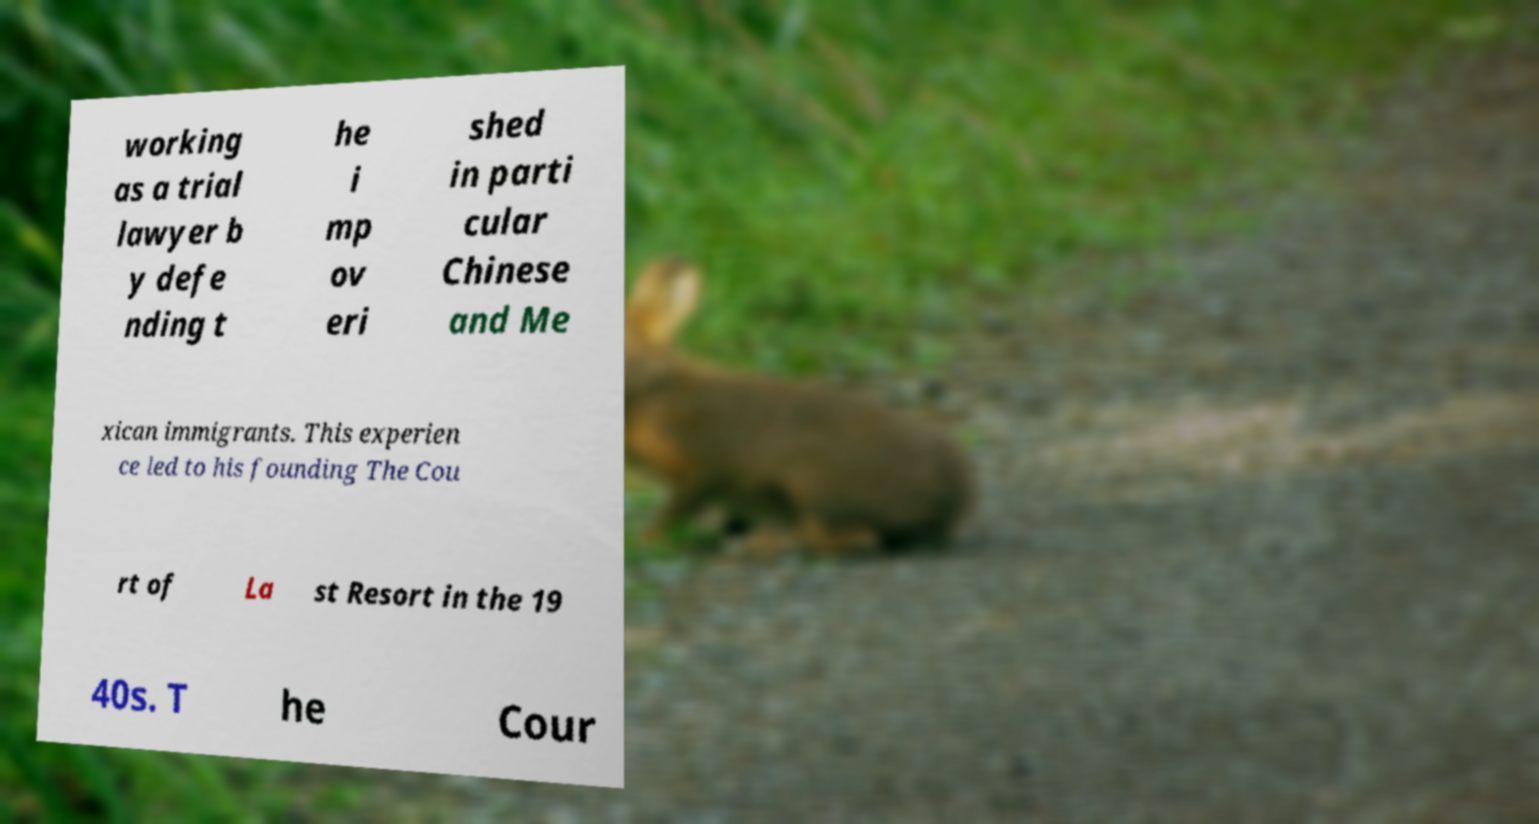What messages or text are displayed in this image? I need them in a readable, typed format. working as a trial lawyer b y defe nding t he i mp ov eri shed in parti cular Chinese and Me xican immigrants. This experien ce led to his founding The Cou rt of La st Resort in the 19 40s. T he Cour 